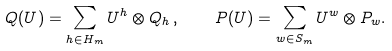Convert formula to latex. <formula><loc_0><loc_0><loc_500><loc_500>Q ( U ) = \sum _ { h \in H _ { m } } U ^ { h } \otimes Q _ { h } \, , \quad P ( U ) = \sum _ { w \in S _ { m } } U ^ { w } \otimes P _ { w } .</formula> 